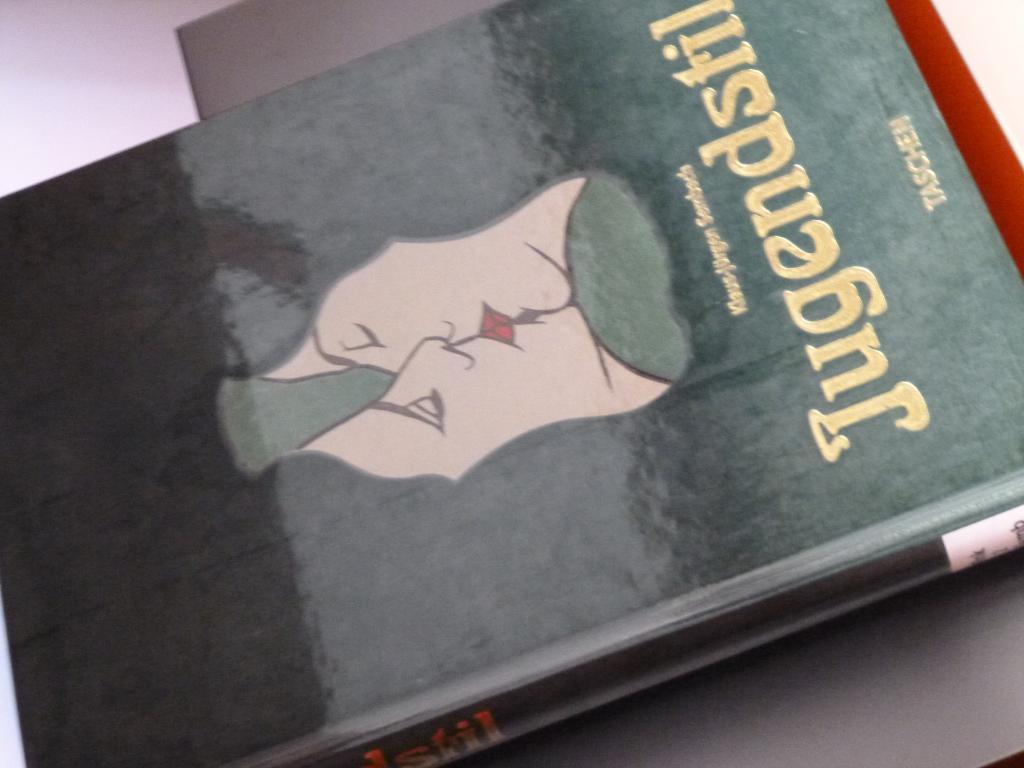Describe this image in one or two sentences. In this Image I can able to see a book on an object. Also a picture and some words are there on the cover of the book. 